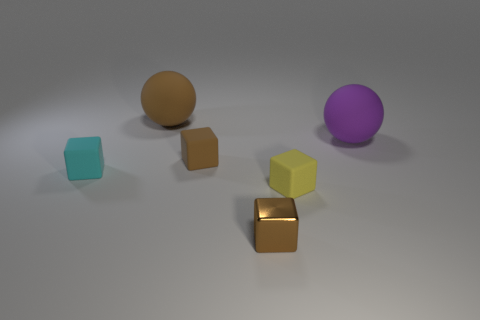How many other objects are there of the same material as the tiny cyan thing?
Ensure brevity in your answer.  4. What material is the brown thing that is the same size as the brown matte cube?
Ensure brevity in your answer.  Metal. Is the number of yellow cubes that are on the right side of the yellow object less than the number of big matte balls?
Offer a terse response. Yes. What is the shape of the large rubber thing left of the matte sphere that is in front of the sphere that is to the left of the yellow cube?
Offer a terse response. Sphere. There is a rubber block that is in front of the cyan cube; what is its size?
Give a very brief answer. Small. What shape is the yellow matte thing that is the same size as the cyan rubber block?
Make the answer very short. Cube. What number of things are big blue matte balls or objects right of the brown rubber cube?
Give a very brief answer. 3. There is a large rubber sphere behind the large purple ball to the right of the tiny yellow matte block; what number of small brown rubber blocks are behind it?
Offer a very short reply. 0. There is a ball that is made of the same material as the purple object; what is its color?
Make the answer very short. Brown. There is a rubber sphere that is to the left of the brown shiny object; is it the same size as the purple matte object?
Your response must be concise. Yes. 